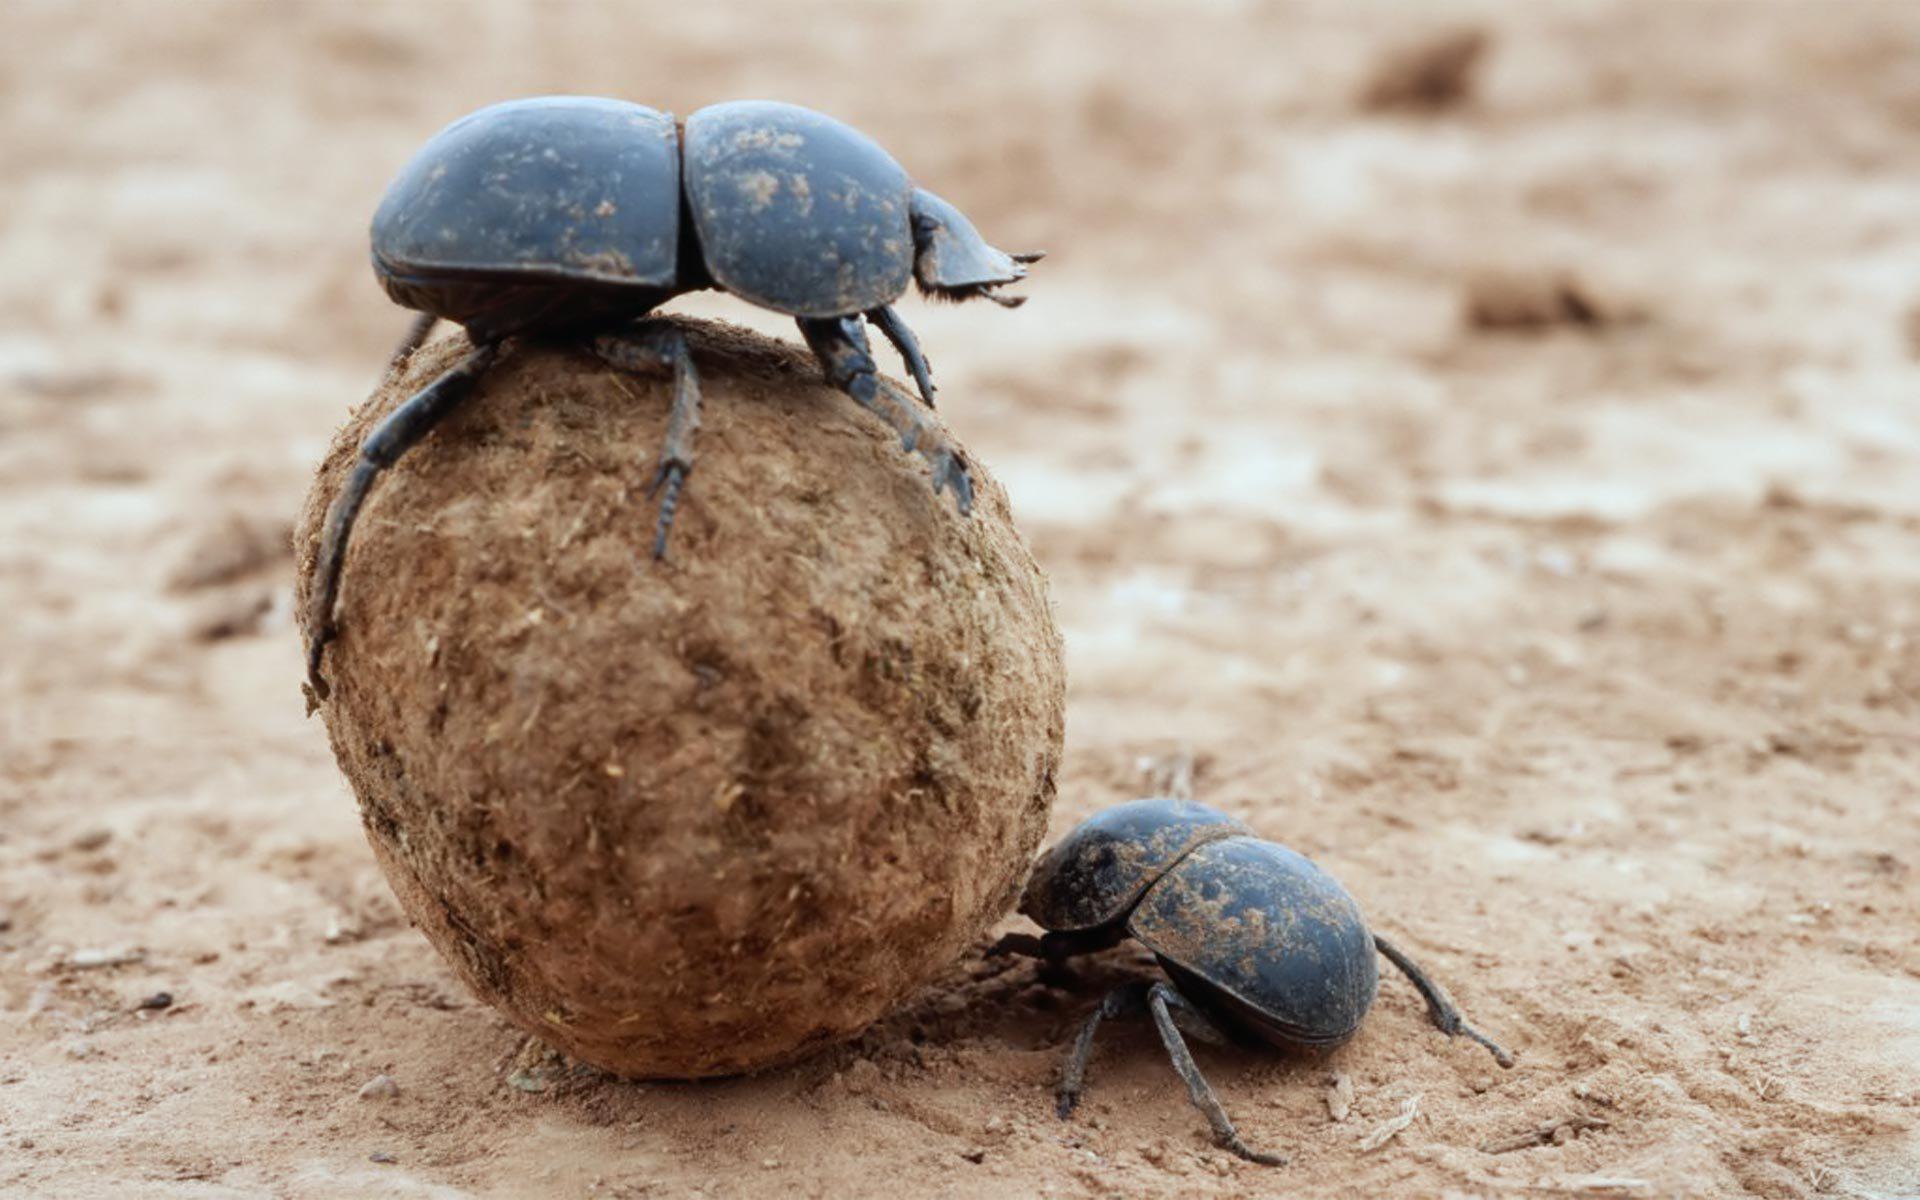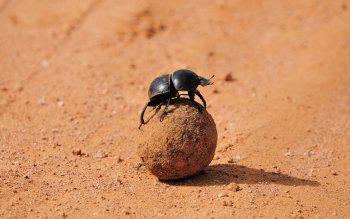The first image is the image on the left, the second image is the image on the right. Examine the images to the left and right. Is the description "There are two beetles in the right image." accurate? Answer yes or no. No. The first image is the image on the left, the second image is the image on the right. Given the left and right images, does the statement "Each image includes at least one beetle in contact with one brown ball." hold true? Answer yes or no. Yes. 